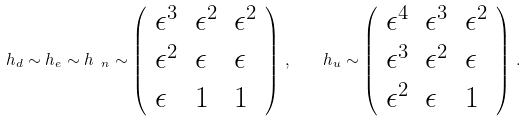Convert formula to latex. <formula><loc_0><loc_0><loc_500><loc_500>h _ { d } \sim h _ { e } \sim h _ { \ n } \sim \left ( \begin{array} { l l l } \epsilon ^ { 3 } & \epsilon ^ { 2 } & \epsilon ^ { 2 } \\ \epsilon ^ { 2 } & \epsilon & \epsilon \\ \epsilon & 1 & 1 \end{array} \right ) \, , \quad h _ { u } \sim \left ( \begin{array} { l l l } \epsilon ^ { 4 } & \epsilon ^ { 3 } & \epsilon ^ { 2 } \\ \epsilon ^ { 3 } & \epsilon ^ { 2 } & \epsilon \\ \epsilon ^ { 2 } & \epsilon & 1 \end{array} \right ) \, .</formula> 